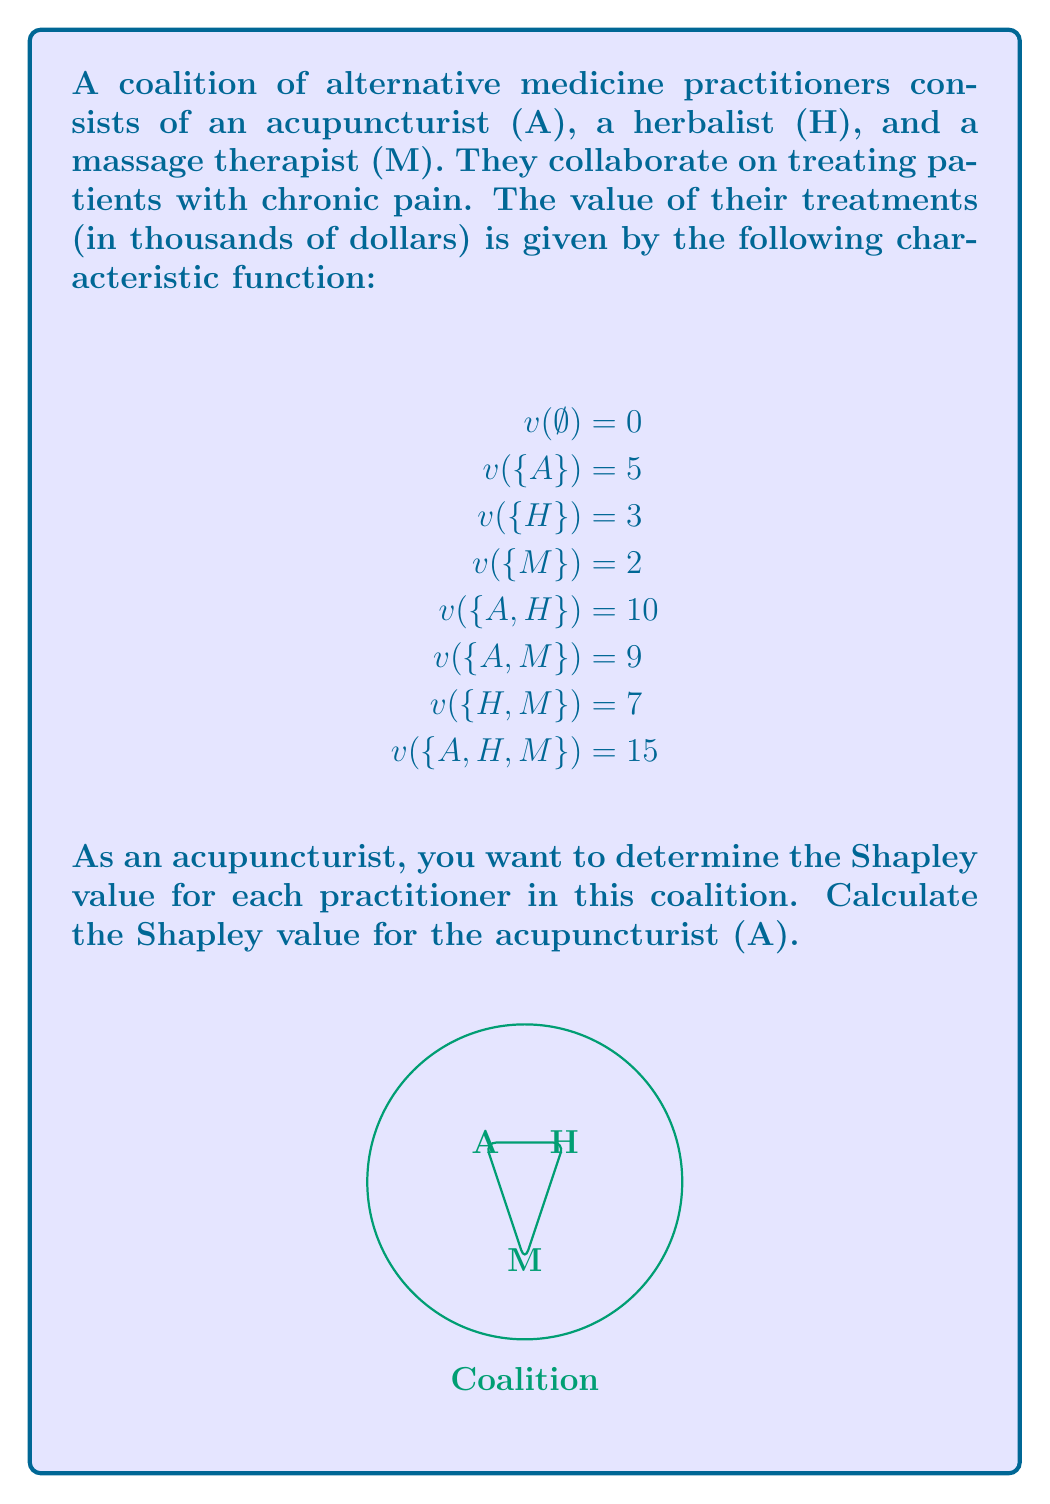Teach me how to tackle this problem. To calculate the Shapley value for the acupuncturist (A), we need to determine their marginal contribution in all possible coalition formations. The Shapley value is the average of these marginal contributions.

There are 3! = 6 possible orderings of the three practitioners:

1. A, H, M
2. A, M, H
3. H, A, M
4. H, M, A
5. M, A, H
6. M, H, A

Let's calculate A's marginal contribution in each ordering:

1. A, H, M: $v(\{A\}) - v(\emptyset) = 5 - 0 = 5$
2. A, M, H: $v(\{A\}) - v(\emptyset) = 5 - 0 = 5$
3. H, A, M: $v(\{H,A\}) - v(\{H\}) = 10 - 3 = 7$
4. H, M, A: $v(\{H,M,A\}) - v(\{H,M\}) = 15 - 7 = 8$
5. M, A, H: $v(\{M,A\}) - v(\{M\}) = 9 - 2 = 7$
6. M, H, A: $v(\{M,H,A\}) - v(\{M,H\}) = 15 - 7 = 8$

The Shapley value is the average of these marginal contributions:

$$\text{Shapley Value}_A = \frac{5 + 5 + 7 + 8 + 7 + 8}{6} = \frac{40}{6} = \frac{20}{3}$$

Therefore, the Shapley value for the acupuncturist (A) is $\frac{20}{3}$ thousand dollars, or approximately $6.67$ thousand dollars.
Answer: $\frac{20}{3}$ thousand dollars 